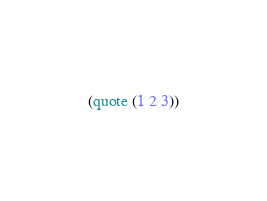<code> <loc_0><loc_0><loc_500><loc_500><_Scheme_>(quote (1 2 3))
</code> 